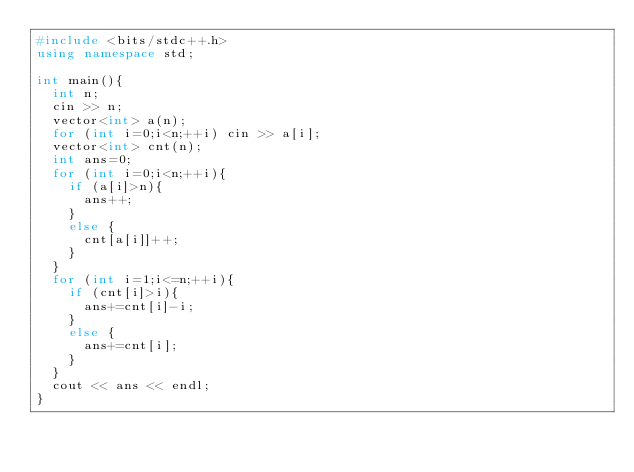<code> <loc_0><loc_0><loc_500><loc_500><_C++_>#include <bits/stdc++.h>
using namespace std;

int main(){
  int n;
  cin >> n;
  vector<int> a(n);
  for (int i=0;i<n;++i) cin >> a[i];
  vector<int> cnt(n);
  int ans=0;
  for (int i=0;i<n;++i){
    if (a[i]>n){
      ans++;
    }
    else {
      cnt[a[i]]++;
    }
  }
  for (int i=1;i<=n;++i){
    if (cnt[i]>i){
      ans+=cnt[i]-i;
    }
    else {
      ans+=cnt[i];
    }
  }
  cout << ans << endl;
}
</code> 